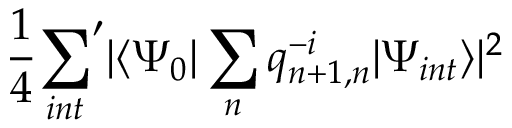<formula> <loc_0><loc_0><loc_500><loc_500>\frac { 1 } { 4 } { \sum _ { i n t } } ^ { \prime } | \langle \Psi _ { 0 } | \sum _ { n } q _ { n + 1 , n } ^ { - i } | \Psi _ { i n t } \rangle | ^ { 2 }</formula> 